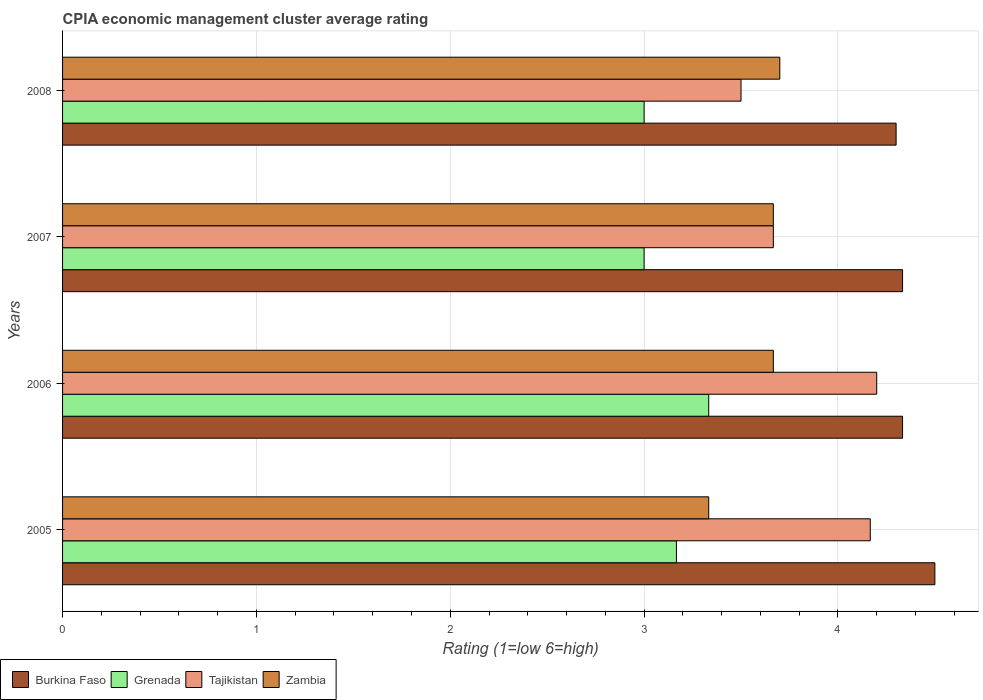How many different coloured bars are there?
Keep it short and to the point. 4. How many groups of bars are there?
Your response must be concise. 4. Are the number of bars per tick equal to the number of legend labels?
Provide a short and direct response. Yes. How many bars are there on the 4th tick from the top?
Keep it short and to the point. 4. How many bars are there on the 3rd tick from the bottom?
Your answer should be very brief. 4. In how many cases, is the number of bars for a given year not equal to the number of legend labels?
Ensure brevity in your answer.  0. What is the CPIA rating in Grenada in 2007?
Your response must be concise. 3. Across all years, what is the maximum CPIA rating in Tajikistan?
Give a very brief answer. 4.2. In which year was the CPIA rating in Burkina Faso minimum?
Give a very brief answer. 2008. What is the total CPIA rating in Grenada in the graph?
Ensure brevity in your answer.  12.5. What is the difference between the CPIA rating in Burkina Faso in 2005 and that in 2008?
Ensure brevity in your answer.  0.2. What is the difference between the CPIA rating in Grenada in 2008 and the CPIA rating in Zambia in 2007?
Your answer should be compact. -0.67. What is the average CPIA rating in Burkina Faso per year?
Your answer should be very brief. 4.37. In the year 2008, what is the difference between the CPIA rating in Zambia and CPIA rating in Tajikistan?
Provide a succinct answer. 0.2. Is the difference between the CPIA rating in Zambia in 2005 and 2007 greater than the difference between the CPIA rating in Tajikistan in 2005 and 2007?
Your answer should be compact. No. What is the difference between the highest and the second highest CPIA rating in Zambia?
Your answer should be very brief. 0.03. What is the difference between the highest and the lowest CPIA rating in Tajikistan?
Make the answer very short. 0.7. Is the sum of the CPIA rating in Zambia in 2007 and 2008 greater than the maximum CPIA rating in Burkina Faso across all years?
Give a very brief answer. Yes. What does the 1st bar from the top in 2008 represents?
Your answer should be very brief. Zambia. What does the 1st bar from the bottom in 2007 represents?
Make the answer very short. Burkina Faso. How many bars are there?
Offer a very short reply. 16. Are all the bars in the graph horizontal?
Your response must be concise. Yes. Does the graph contain any zero values?
Provide a succinct answer. No. Does the graph contain grids?
Ensure brevity in your answer.  Yes. Where does the legend appear in the graph?
Your answer should be compact. Bottom left. How many legend labels are there?
Ensure brevity in your answer.  4. How are the legend labels stacked?
Keep it short and to the point. Horizontal. What is the title of the graph?
Provide a succinct answer. CPIA economic management cluster average rating. What is the label or title of the X-axis?
Keep it short and to the point. Rating (1=low 6=high). What is the Rating (1=low 6=high) of Grenada in 2005?
Provide a short and direct response. 3.17. What is the Rating (1=low 6=high) in Tajikistan in 2005?
Offer a very short reply. 4.17. What is the Rating (1=low 6=high) in Zambia in 2005?
Offer a terse response. 3.33. What is the Rating (1=low 6=high) of Burkina Faso in 2006?
Provide a short and direct response. 4.33. What is the Rating (1=low 6=high) in Grenada in 2006?
Your answer should be compact. 3.33. What is the Rating (1=low 6=high) of Zambia in 2006?
Provide a succinct answer. 3.67. What is the Rating (1=low 6=high) in Burkina Faso in 2007?
Keep it short and to the point. 4.33. What is the Rating (1=low 6=high) of Grenada in 2007?
Offer a very short reply. 3. What is the Rating (1=low 6=high) of Tajikistan in 2007?
Your response must be concise. 3.67. What is the Rating (1=low 6=high) in Zambia in 2007?
Provide a short and direct response. 3.67. What is the Rating (1=low 6=high) of Burkina Faso in 2008?
Give a very brief answer. 4.3. What is the Rating (1=low 6=high) in Tajikistan in 2008?
Offer a very short reply. 3.5. What is the Rating (1=low 6=high) of Zambia in 2008?
Offer a terse response. 3.7. Across all years, what is the maximum Rating (1=low 6=high) in Grenada?
Your response must be concise. 3.33. Across all years, what is the maximum Rating (1=low 6=high) in Tajikistan?
Your answer should be compact. 4.2. Across all years, what is the minimum Rating (1=low 6=high) of Tajikistan?
Your response must be concise. 3.5. Across all years, what is the minimum Rating (1=low 6=high) in Zambia?
Your response must be concise. 3.33. What is the total Rating (1=low 6=high) in Burkina Faso in the graph?
Your response must be concise. 17.47. What is the total Rating (1=low 6=high) of Grenada in the graph?
Give a very brief answer. 12.5. What is the total Rating (1=low 6=high) of Tajikistan in the graph?
Keep it short and to the point. 15.53. What is the total Rating (1=low 6=high) of Zambia in the graph?
Offer a very short reply. 14.37. What is the difference between the Rating (1=low 6=high) in Grenada in 2005 and that in 2006?
Give a very brief answer. -0.17. What is the difference between the Rating (1=low 6=high) in Tajikistan in 2005 and that in 2006?
Offer a terse response. -0.03. What is the difference between the Rating (1=low 6=high) in Zambia in 2005 and that in 2006?
Your response must be concise. -0.33. What is the difference between the Rating (1=low 6=high) in Burkina Faso in 2005 and that in 2007?
Keep it short and to the point. 0.17. What is the difference between the Rating (1=low 6=high) of Grenada in 2005 and that in 2007?
Make the answer very short. 0.17. What is the difference between the Rating (1=low 6=high) in Tajikistan in 2005 and that in 2007?
Your answer should be very brief. 0.5. What is the difference between the Rating (1=low 6=high) in Burkina Faso in 2005 and that in 2008?
Your answer should be very brief. 0.2. What is the difference between the Rating (1=low 6=high) of Tajikistan in 2005 and that in 2008?
Your response must be concise. 0.67. What is the difference between the Rating (1=low 6=high) of Zambia in 2005 and that in 2008?
Offer a terse response. -0.37. What is the difference between the Rating (1=low 6=high) of Grenada in 2006 and that in 2007?
Your answer should be compact. 0.33. What is the difference between the Rating (1=low 6=high) in Tajikistan in 2006 and that in 2007?
Your answer should be very brief. 0.53. What is the difference between the Rating (1=low 6=high) in Burkina Faso in 2006 and that in 2008?
Your answer should be compact. 0.03. What is the difference between the Rating (1=low 6=high) in Zambia in 2006 and that in 2008?
Give a very brief answer. -0.03. What is the difference between the Rating (1=low 6=high) of Zambia in 2007 and that in 2008?
Offer a terse response. -0.03. What is the difference between the Rating (1=low 6=high) of Burkina Faso in 2005 and the Rating (1=low 6=high) of Tajikistan in 2006?
Keep it short and to the point. 0.3. What is the difference between the Rating (1=low 6=high) in Grenada in 2005 and the Rating (1=low 6=high) in Tajikistan in 2006?
Provide a short and direct response. -1.03. What is the difference between the Rating (1=low 6=high) of Tajikistan in 2005 and the Rating (1=low 6=high) of Zambia in 2006?
Offer a terse response. 0.5. What is the difference between the Rating (1=low 6=high) of Grenada in 2005 and the Rating (1=low 6=high) of Zambia in 2007?
Your answer should be compact. -0.5. What is the difference between the Rating (1=low 6=high) of Burkina Faso in 2005 and the Rating (1=low 6=high) of Tajikistan in 2008?
Make the answer very short. 1. What is the difference between the Rating (1=low 6=high) of Burkina Faso in 2005 and the Rating (1=low 6=high) of Zambia in 2008?
Provide a succinct answer. 0.8. What is the difference between the Rating (1=low 6=high) of Grenada in 2005 and the Rating (1=low 6=high) of Tajikistan in 2008?
Provide a short and direct response. -0.33. What is the difference between the Rating (1=low 6=high) in Grenada in 2005 and the Rating (1=low 6=high) in Zambia in 2008?
Give a very brief answer. -0.53. What is the difference between the Rating (1=low 6=high) of Tajikistan in 2005 and the Rating (1=low 6=high) of Zambia in 2008?
Provide a short and direct response. 0.47. What is the difference between the Rating (1=low 6=high) of Burkina Faso in 2006 and the Rating (1=low 6=high) of Tajikistan in 2007?
Offer a very short reply. 0.67. What is the difference between the Rating (1=low 6=high) in Burkina Faso in 2006 and the Rating (1=low 6=high) in Zambia in 2007?
Keep it short and to the point. 0.67. What is the difference between the Rating (1=low 6=high) of Tajikistan in 2006 and the Rating (1=low 6=high) of Zambia in 2007?
Give a very brief answer. 0.53. What is the difference between the Rating (1=low 6=high) in Burkina Faso in 2006 and the Rating (1=low 6=high) in Grenada in 2008?
Your answer should be compact. 1.33. What is the difference between the Rating (1=low 6=high) in Burkina Faso in 2006 and the Rating (1=low 6=high) in Zambia in 2008?
Offer a terse response. 0.63. What is the difference between the Rating (1=low 6=high) of Grenada in 2006 and the Rating (1=low 6=high) of Tajikistan in 2008?
Your response must be concise. -0.17. What is the difference between the Rating (1=low 6=high) of Grenada in 2006 and the Rating (1=low 6=high) of Zambia in 2008?
Provide a succinct answer. -0.37. What is the difference between the Rating (1=low 6=high) of Tajikistan in 2006 and the Rating (1=low 6=high) of Zambia in 2008?
Offer a terse response. 0.5. What is the difference between the Rating (1=low 6=high) in Burkina Faso in 2007 and the Rating (1=low 6=high) in Grenada in 2008?
Keep it short and to the point. 1.33. What is the difference between the Rating (1=low 6=high) of Burkina Faso in 2007 and the Rating (1=low 6=high) of Zambia in 2008?
Keep it short and to the point. 0.63. What is the difference between the Rating (1=low 6=high) in Grenada in 2007 and the Rating (1=low 6=high) in Tajikistan in 2008?
Ensure brevity in your answer.  -0.5. What is the difference between the Rating (1=low 6=high) of Tajikistan in 2007 and the Rating (1=low 6=high) of Zambia in 2008?
Give a very brief answer. -0.03. What is the average Rating (1=low 6=high) of Burkina Faso per year?
Offer a very short reply. 4.37. What is the average Rating (1=low 6=high) in Grenada per year?
Offer a terse response. 3.12. What is the average Rating (1=low 6=high) of Tajikistan per year?
Give a very brief answer. 3.88. What is the average Rating (1=low 6=high) of Zambia per year?
Offer a terse response. 3.59. In the year 2005, what is the difference between the Rating (1=low 6=high) of Burkina Faso and Rating (1=low 6=high) of Tajikistan?
Offer a terse response. 0.33. In the year 2005, what is the difference between the Rating (1=low 6=high) in Grenada and Rating (1=low 6=high) in Tajikistan?
Offer a terse response. -1. In the year 2006, what is the difference between the Rating (1=low 6=high) of Burkina Faso and Rating (1=low 6=high) of Tajikistan?
Offer a very short reply. 0.13. In the year 2006, what is the difference between the Rating (1=low 6=high) in Burkina Faso and Rating (1=low 6=high) in Zambia?
Provide a short and direct response. 0.67. In the year 2006, what is the difference between the Rating (1=low 6=high) of Grenada and Rating (1=low 6=high) of Tajikistan?
Provide a succinct answer. -0.87. In the year 2006, what is the difference between the Rating (1=low 6=high) in Tajikistan and Rating (1=low 6=high) in Zambia?
Your response must be concise. 0.53. In the year 2007, what is the difference between the Rating (1=low 6=high) in Burkina Faso and Rating (1=low 6=high) in Grenada?
Provide a short and direct response. 1.33. In the year 2007, what is the difference between the Rating (1=low 6=high) of Grenada and Rating (1=low 6=high) of Tajikistan?
Provide a short and direct response. -0.67. In the year 2007, what is the difference between the Rating (1=low 6=high) in Tajikistan and Rating (1=low 6=high) in Zambia?
Keep it short and to the point. 0. In the year 2008, what is the difference between the Rating (1=low 6=high) in Burkina Faso and Rating (1=low 6=high) in Tajikistan?
Ensure brevity in your answer.  0.8. In the year 2008, what is the difference between the Rating (1=low 6=high) in Burkina Faso and Rating (1=low 6=high) in Zambia?
Your answer should be compact. 0.6. In the year 2008, what is the difference between the Rating (1=low 6=high) of Grenada and Rating (1=low 6=high) of Tajikistan?
Provide a succinct answer. -0.5. What is the ratio of the Rating (1=low 6=high) in Tajikistan in 2005 to that in 2006?
Your response must be concise. 0.99. What is the ratio of the Rating (1=low 6=high) of Burkina Faso in 2005 to that in 2007?
Make the answer very short. 1.04. What is the ratio of the Rating (1=low 6=high) of Grenada in 2005 to that in 2007?
Provide a succinct answer. 1.06. What is the ratio of the Rating (1=low 6=high) in Tajikistan in 2005 to that in 2007?
Give a very brief answer. 1.14. What is the ratio of the Rating (1=low 6=high) in Burkina Faso in 2005 to that in 2008?
Ensure brevity in your answer.  1.05. What is the ratio of the Rating (1=low 6=high) in Grenada in 2005 to that in 2008?
Provide a short and direct response. 1.06. What is the ratio of the Rating (1=low 6=high) in Tajikistan in 2005 to that in 2008?
Keep it short and to the point. 1.19. What is the ratio of the Rating (1=low 6=high) of Zambia in 2005 to that in 2008?
Provide a short and direct response. 0.9. What is the ratio of the Rating (1=low 6=high) of Tajikistan in 2006 to that in 2007?
Ensure brevity in your answer.  1.15. What is the ratio of the Rating (1=low 6=high) of Zambia in 2006 to that in 2007?
Your answer should be very brief. 1. What is the ratio of the Rating (1=low 6=high) in Zambia in 2006 to that in 2008?
Provide a succinct answer. 0.99. What is the ratio of the Rating (1=low 6=high) of Grenada in 2007 to that in 2008?
Keep it short and to the point. 1. What is the ratio of the Rating (1=low 6=high) of Tajikistan in 2007 to that in 2008?
Your answer should be compact. 1.05. What is the difference between the highest and the second highest Rating (1=low 6=high) of Grenada?
Provide a succinct answer. 0.17. What is the difference between the highest and the second highest Rating (1=low 6=high) of Tajikistan?
Offer a very short reply. 0.03. What is the difference between the highest and the second highest Rating (1=low 6=high) in Zambia?
Give a very brief answer. 0.03. What is the difference between the highest and the lowest Rating (1=low 6=high) in Burkina Faso?
Offer a terse response. 0.2. What is the difference between the highest and the lowest Rating (1=low 6=high) in Grenada?
Make the answer very short. 0.33. What is the difference between the highest and the lowest Rating (1=low 6=high) of Tajikistan?
Make the answer very short. 0.7. What is the difference between the highest and the lowest Rating (1=low 6=high) of Zambia?
Ensure brevity in your answer.  0.37. 